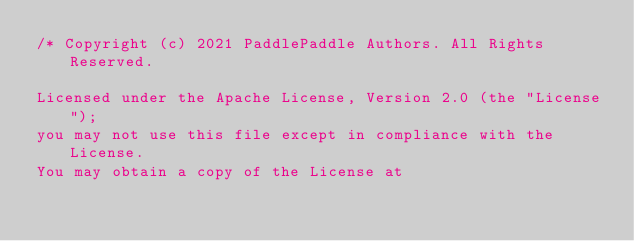<code> <loc_0><loc_0><loc_500><loc_500><_Cuda_>/* Copyright (c) 2021 PaddlePaddle Authors. All Rights Reserved.

Licensed under the Apache License, Version 2.0 (the "License");
you may not use this file except in compliance with the License.
You may obtain a copy of the License at
</code> 